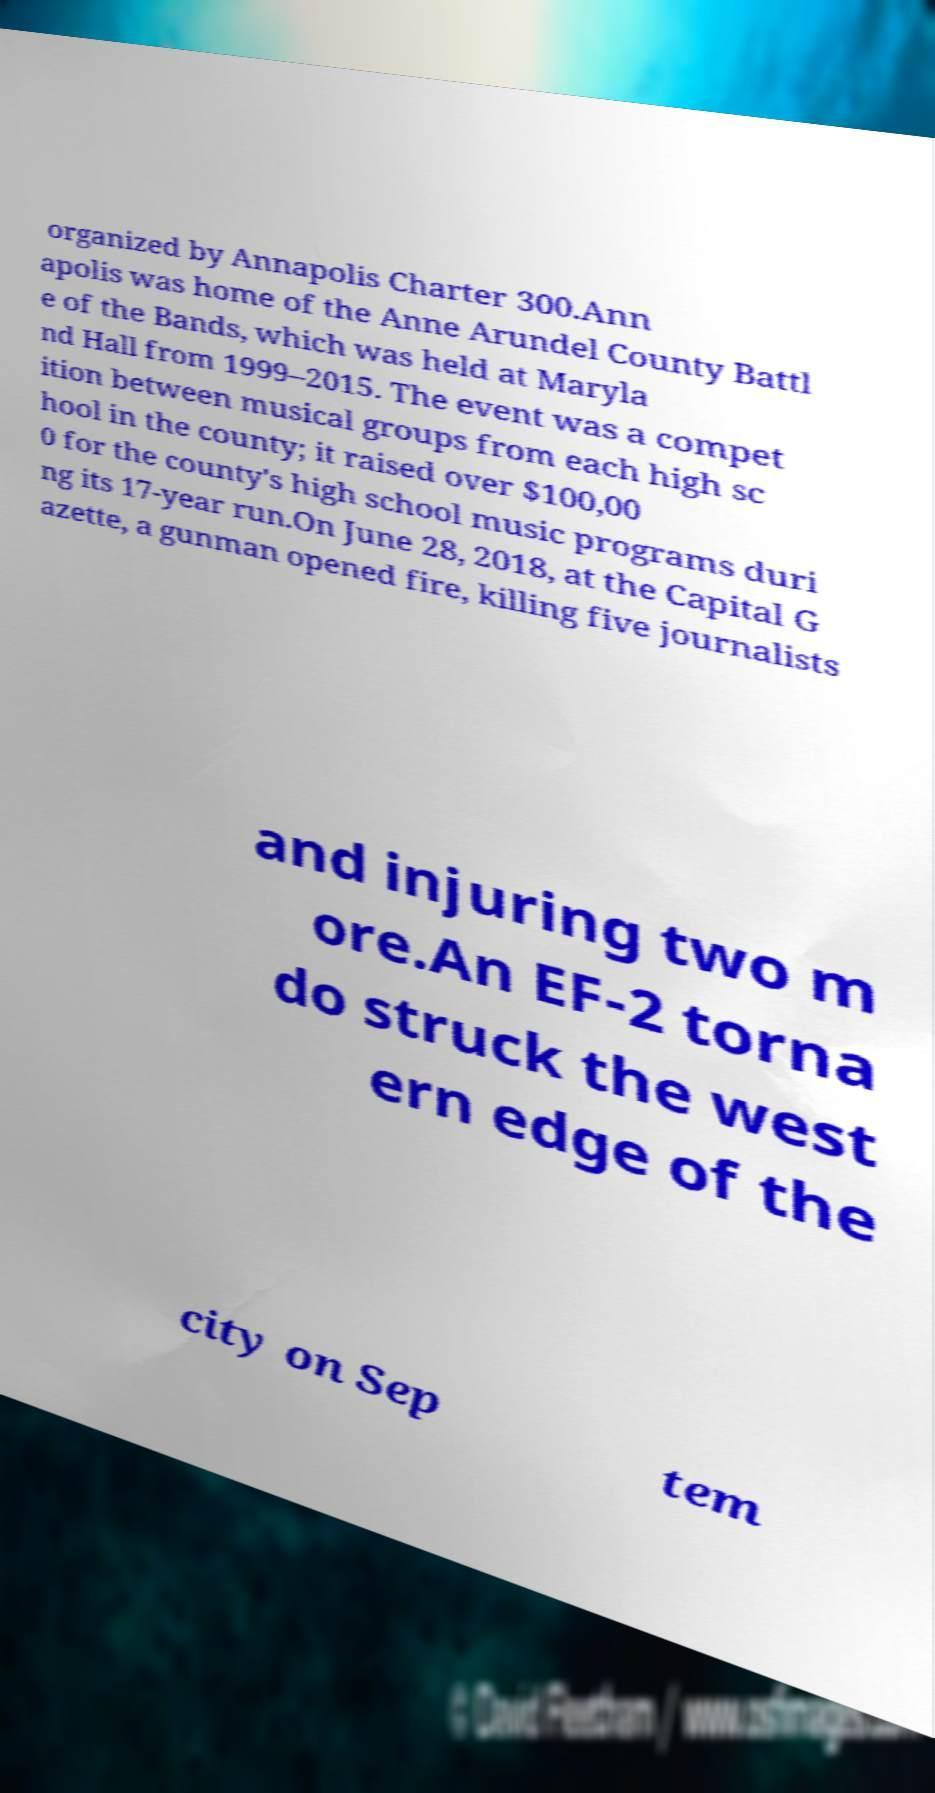Please identify and transcribe the text found in this image. organized by Annapolis Charter 300.Ann apolis was home of the Anne Arundel County Battl e of the Bands, which was held at Maryla nd Hall from 1999–2015. The event was a compet ition between musical groups from each high sc hool in the county; it raised over $100,00 0 for the county's high school music programs duri ng its 17-year run.On June 28, 2018, at the Capital G azette, a gunman opened fire, killing five journalists and injuring two m ore.An EF-2 torna do struck the west ern edge of the city on Sep tem 